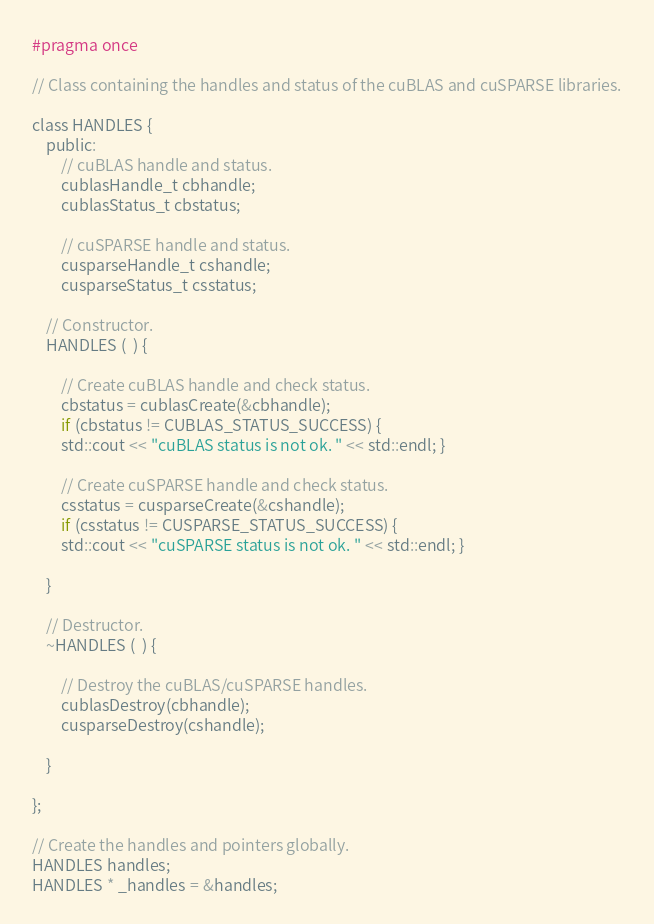Convert code to text. <code><loc_0><loc_0><loc_500><loc_500><_C_>#pragma once

// Class containing the handles and status of the cuBLAS and cuSPARSE libraries.

class HANDLES {
    public:
        // cuBLAS handle and status.
        cublasHandle_t cbhandle;
        cublasStatus_t cbstatus;

        // cuSPARSE handle and status.
        cusparseHandle_t cshandle;
        cusparseStatus_t csstatus;

    // Constructor.
    HANDLES (  ) {

        // Create cuBLAS handle and check status.
        cbstatus = cublasCreate(&cbhandle);
        if (cbstatus != CUBLAS_STATUS_SUCCESS) {
        std::cout << "cuBLAS status is not ok. " << std::endl; }

        // Create cuSPARSE handle and check status.
        csstatus = cusparseCreate(&cshandle);
        if (csstatus != CUSPARSE_STATUS_SUCCESS) {
        std::cout << "cuSPARSE status is not ok. " << std::endl; }

    }

    // Destructor.
    ~HANDLES (  ) {

        // Destroy the cuBLAS/cuSPARSE handles.
        cublasDestroy(cbhandle);
        cusparseDestroy(cshandle);

    }

};

// Create the handles and pointers globally.
HANDLES handles;
HANDLES * _handles = &handles;</code> 